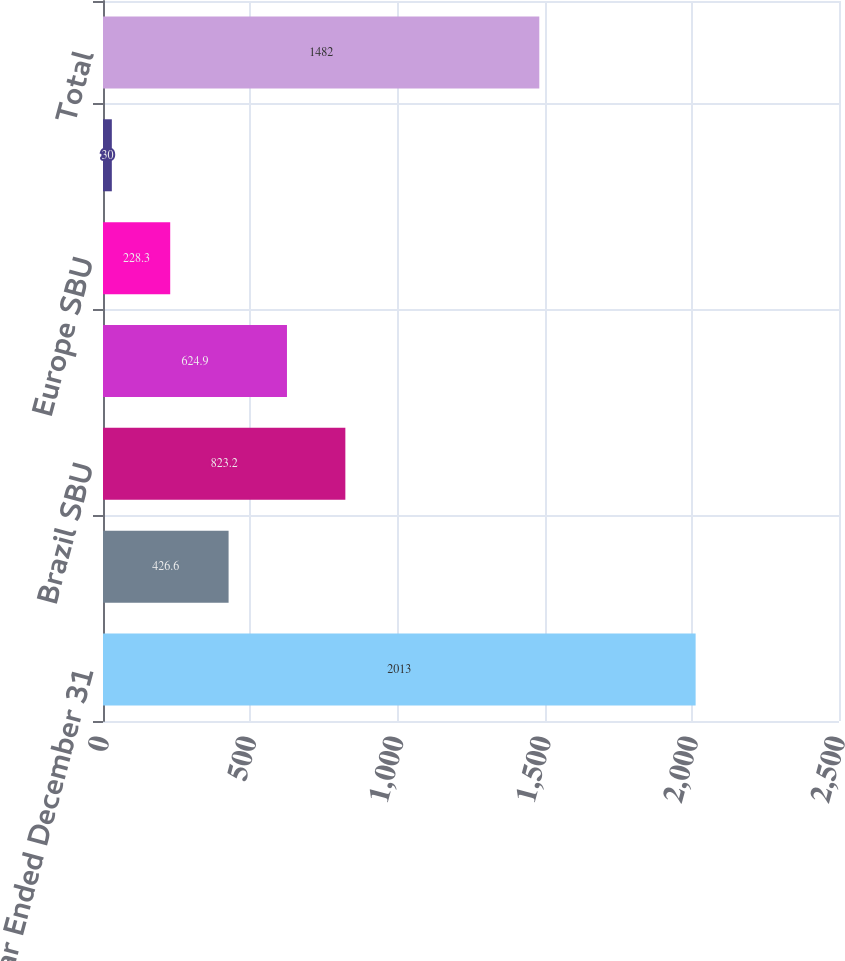<chart> <loc_0><loc_0><loc_500><loc_500><bar_chart><fcel>Year Ended December 31<fcel>Andes SBU<fcel>Brazil SBU<fcel>MCAC SBU<fcel>Europe SBU<fcel>Asia SBU<fcel>Total<nl><fcel>2013<fcel>426.6<fcel>823.2<fcel>624.9<fcel>228.3<fcel>30<fcel>1482<nl></chart> 